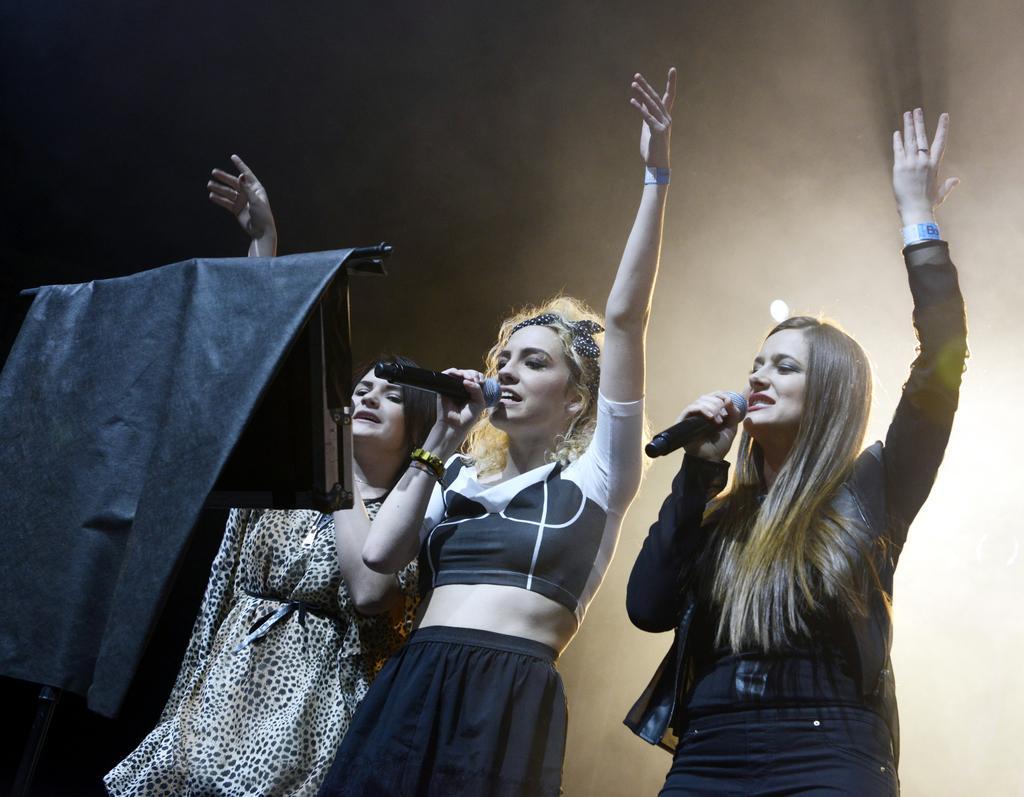How would you summarize this image in a sentence or two? In this picture there are three women standing and holding a mic in their hands and singing in front of it and there is a stand in front of them. 